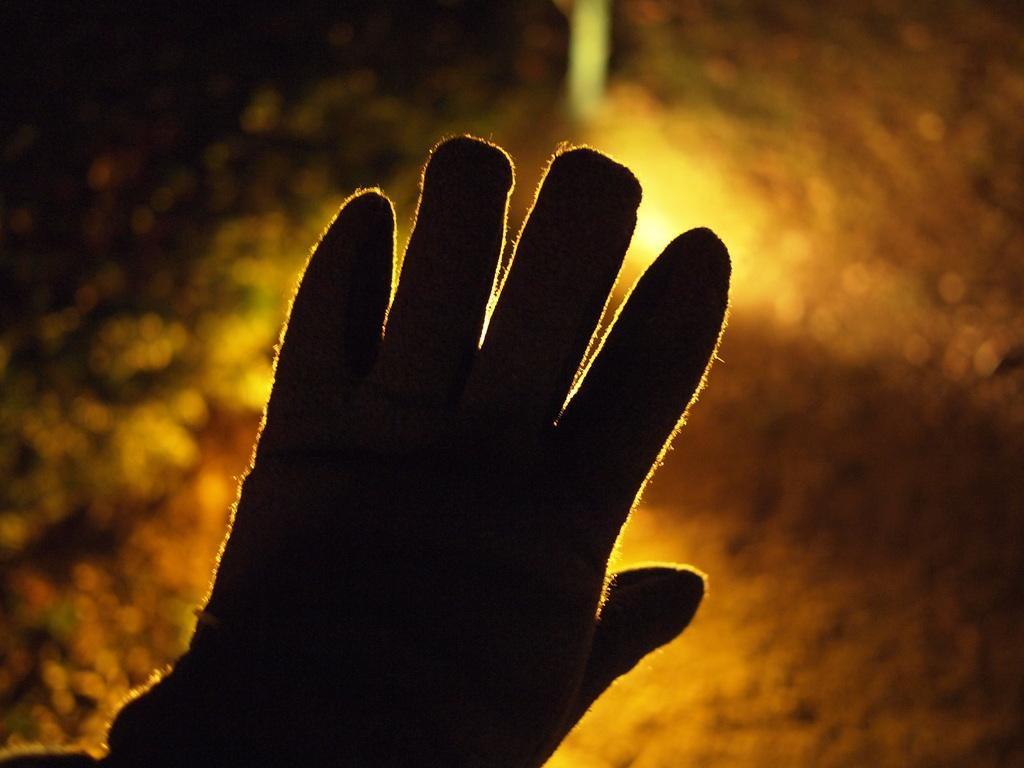How would you summarize this image in a sentence or two? In this image we can see some person's hand and we can also see the person wearing the hand gloves and the background is unclear with lightning. 